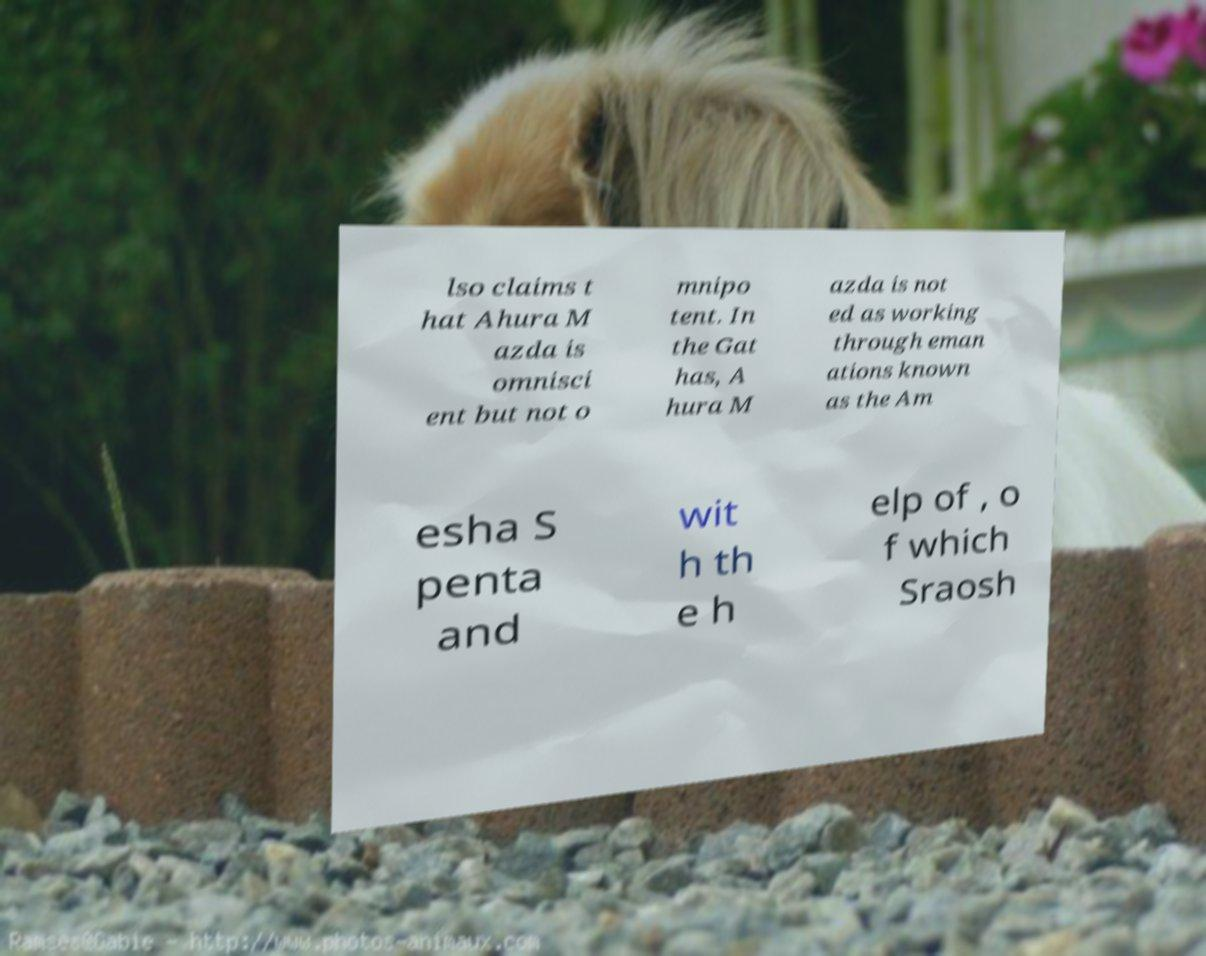There's text embedded in this image that I need extracted. Can you transcribe it verbatim? lso claims t hat Ahura M azda is omnisci ent but not o mnipo tent. In the Gat has, A hura M azda is not ed as working through eman ations known as the Am esha S penta and wit h th e h elp of , o f which Sraosh 